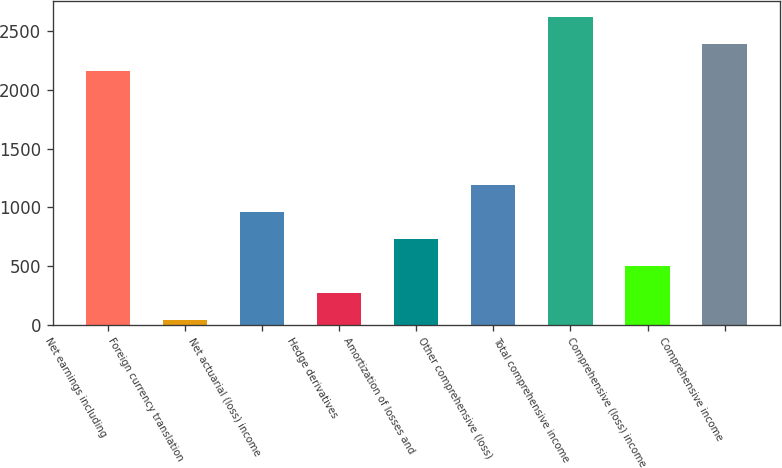Convert chart. <chart><loc_0><loc_0><loc_500><loc_500><bar_chart><fcel>Net earnings including<fcel>Foreign currency translation<fcel>Net actuarial (loss) income<fcel>Hedge derivatives<fcel>Amortization of losses and<fcel>Other comprehensive (loss)<fcel>Total comprehensive income<fcel>Comprehensive (loss) income<fcel>Comprehensive income<nl><fcel>2163<fcel>37<fcel>960.76<fcel>267.94<fcel>729.82<fcel>1191.7<fcel>2624.88<fcel>498.88<fcel>2393.94<nl></chart> 